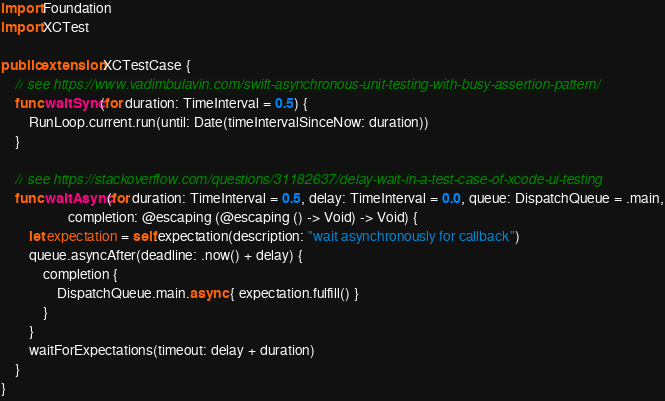<code> <loc_0><loc_0><loc_500><loc_500><_Swift_>import Foundation
import XCTest

public extension XCTestCase {
    // see https://www.vadimbulavin.com/swift-asynchronous-unit-testing-with-busy-assertion-pattern/
    func waitSync(for duration: TimeInterval = 0.5) {
        RunLoop.current.run(until: Date(timeIntervalSinceNow: duration))
    }

    // see https://stackoverflow.com/questions/31182637/delay-wait-in-a-test-case-of-xcode-ui-testing
    func waitAsync(for duration: TimeInterval = 0.5, delay: TimeInterval = 0.0, queue: DispatchQueue = .main,
                   completion: @escaping (@escaping () -> Void) -> Void) {
        let expectation = self.expectation(description: "wait asynchronously for callback")
        queue.asyncAfter(deadline: .now() + delay) {
            completion {
                DispatchQueue.main.async { expectation.fulfill() }
            }
        }
        waitForExpectations(timeout: delay + duration)
    }
}
</code> 